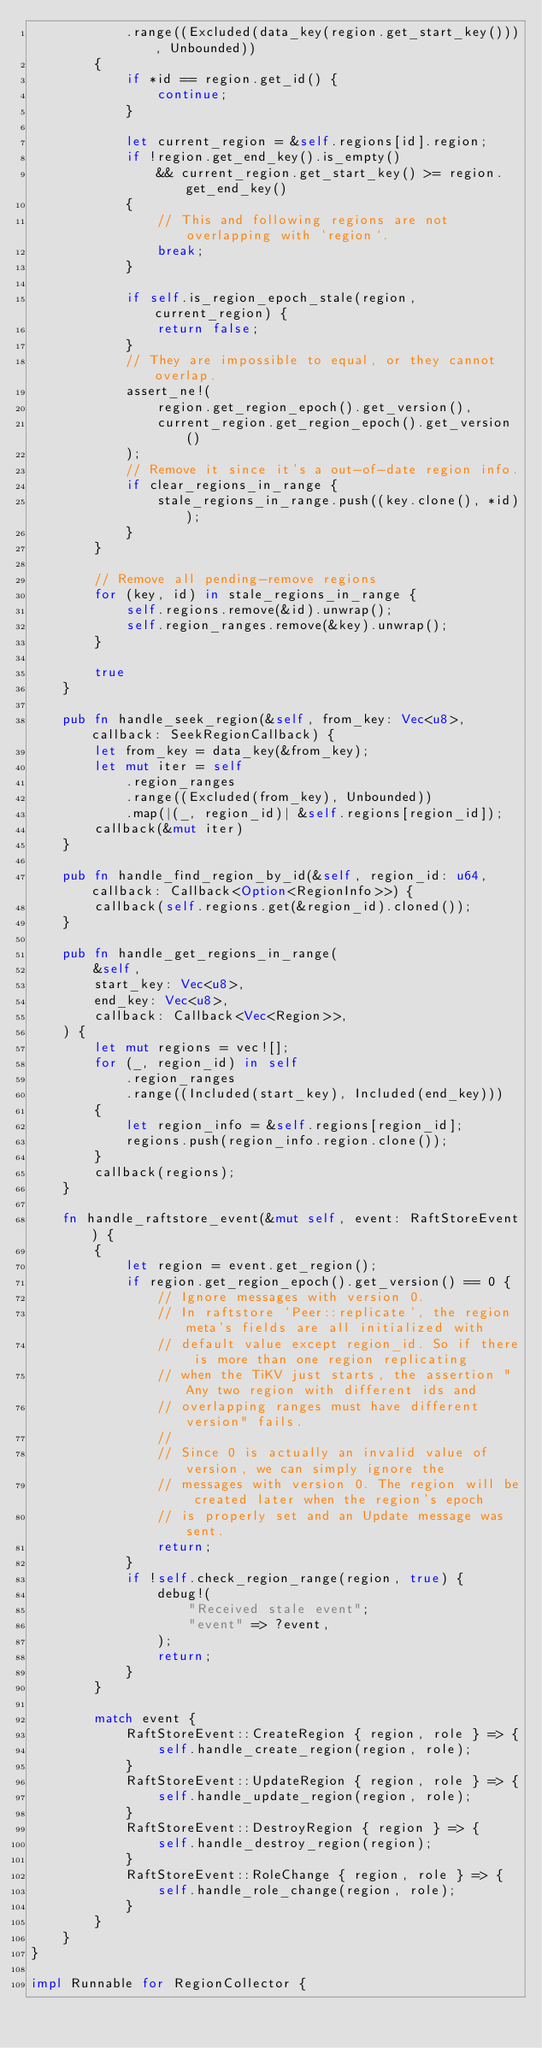<code> <loc_0><loc_0><loc_500><loc_500><_Rust_>            .range((Excluded(data_key(region.get_start_key())), Unbounded))
        {
            if *id == region.get_id() {
                continue;
            }

            let current_region = &self.regions[id].region;
            if !region.get_end_key().is_empty()
                && current_region.get_start_key() >= region.get_end_key()
            {
                // This and following regions are not overlapping with `region`.
                break;
            }

            if self.is_region_epoch_stale(region, current_region) {
                return false;
            }
            // They are impossible to equal, or they cannot overlap.
            assert_ne!(
                region.get_region_epoch().get_version(),
                current_region.get_region_epoch().get_version()
            );
            // Remove it since it's a out-of-date region info.
            if clear_regions_in_range {
                stale_regions_in_range.push((key.clone(), *id));
            }
        }

        // Remove all pending-remove regions
        for (key, id) in stale_regions_in_range {
            self.regions.remove(&id).unwrap();
            self.region_ranges.remove(&key).unwrap();
        }

        true
    }

    pub fn handle_seek_region(&self, from_key: Vec<u8>, callback: SeekRegionCallback) {
        let from_key = data_key(&from_key);
        let mut iter = self
            .region_ranges
            .range((Excluded(from_key), Unbounded))
            .map(|(_, region_id)| &self.regions[region_id]);
        callback(&mut iter)
    }

    pub fn handle_find_region_by_id(&self, region_id: u64, callback: Callback<Option<RegionInfo>>) {
        callback(self.regions.get(&region_id).cloned());
    }

    pub fn handle_get_regions_in_range(
        &self,
        start_key: Vec<u8>,
        end_key: Vec<u8>,
        callback: Callback<Vec<Region>>,
    ) {
        let mut regions = vec![];
        for (_, region_id) in self
            .region_ranges
            .range((Included(start_key), Included(end_key)))
        {
            let region_info = &self.regions[region_id];
            regions.push(region_info.region.clone());
        }
        callback(regions);
    }

    fn handle_raftstore_event(&mut self, event: RaftStoreEvent) {
        {
            let region = event.get_region();
            if region.get_region_epoch().get_version() == 0 {
                // Ignore messages with version 0.
                // In raftstore `Peer::replicate`, the region meta's fields are all initialized with
                // default value except region_id. So if there is more than one region replicating
                // when the TiKV just starts, the assertion "Any two region with different ids and
                // overlapping ranges must have different version" fails.
                //
                // Since 0 is actually an invalid value of version, we can simply ignore the
                // messages with version 0. The region will be created later when the region's epoch
                // is properly set and an Update message was sent.
                return;
            }
            if !self.check_region_range(region, true) {
                debug!(
                    "Received stale event";
                    "event" => ?event,
                );
                return;
            }
        }

        match event {
            RaftStoreEvent::CreateRegion { region, role } => {
                self.handle_create_region(region, role);
            }
            RaftStoreEvent::UpdateRegion { region, role } => {
                self.handle_update_region(region, role);
            }
            RaftStoreEvent::DestroyRegion { region } => {
                self.handle_destroy_region(region);
            }
            RaftStoreEvent::RoleChange { region, role } => {
                self.handle_role_change(region, role);
            }
        }
    }
}

impl Runnable for RegionCollector {</code> 